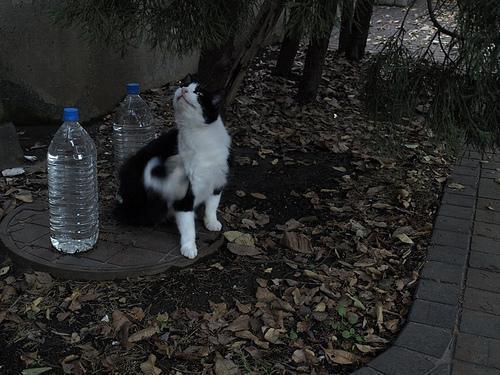How many cats are in this photo?
Give a very brief answer. 1. How many pets are shown?
Give a very brief answer. 1. How many cats?
Give a very brief answer. 1. How many bottles are there?
Give a very brief answer. 2. How many people are shown?
Give a very brief answer. 0. 